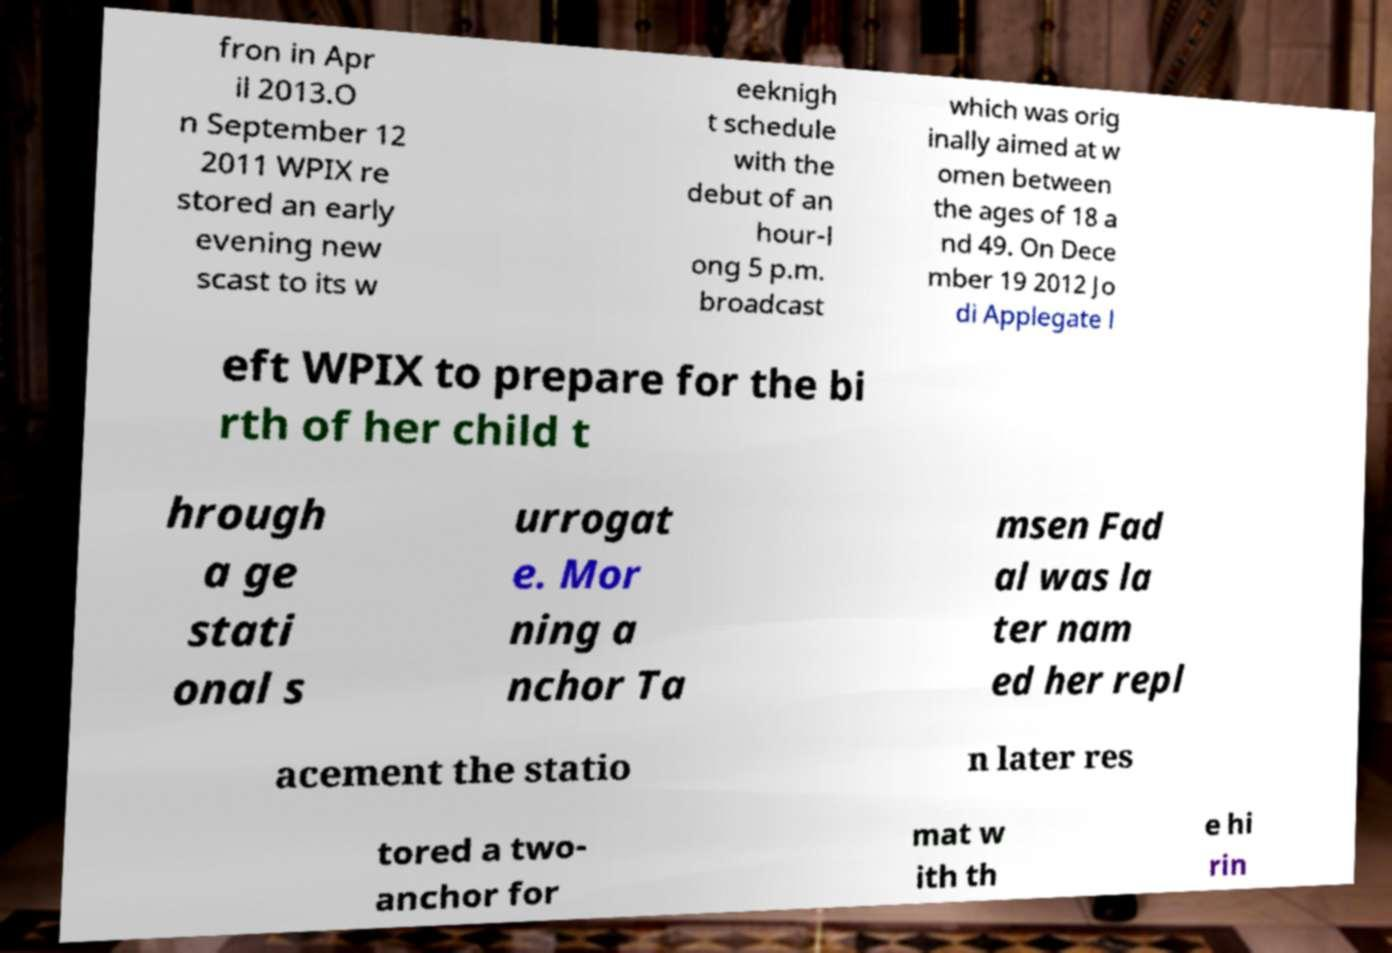Please read and relay the text visible in this image. What does it say? fron in Apr il 2013.O n September 12 2011 WPIX re stored an early evening new scast to its w eeknigh t schedule with the debut of an hour-l ong 5 p.m. broadcast which was orig inally aimed at w omen between the ages of 18 a nd 49. On Dece mber 19 2012 Jo di Applegate l eft WPIX to prepare for the bi rth of her child t hrough a ge stati onal s urrogat e. Mor ning a nchor Ta msen Fad al was la ter nam ed her repl acement the statio n later res tored a two- anchor for mat w ith th e hi rin 